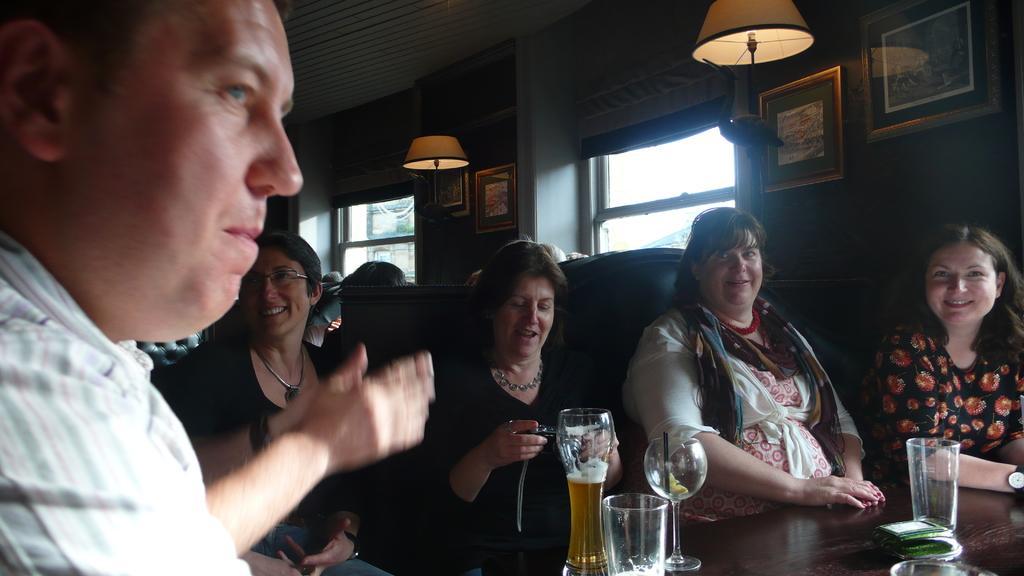Describe this image in one or two sentences. In this image I can see group of people sitting, in front I can see few glasses on the table. Background I can see few frames attached to the wall, two glass windows and I can see two lamps. 